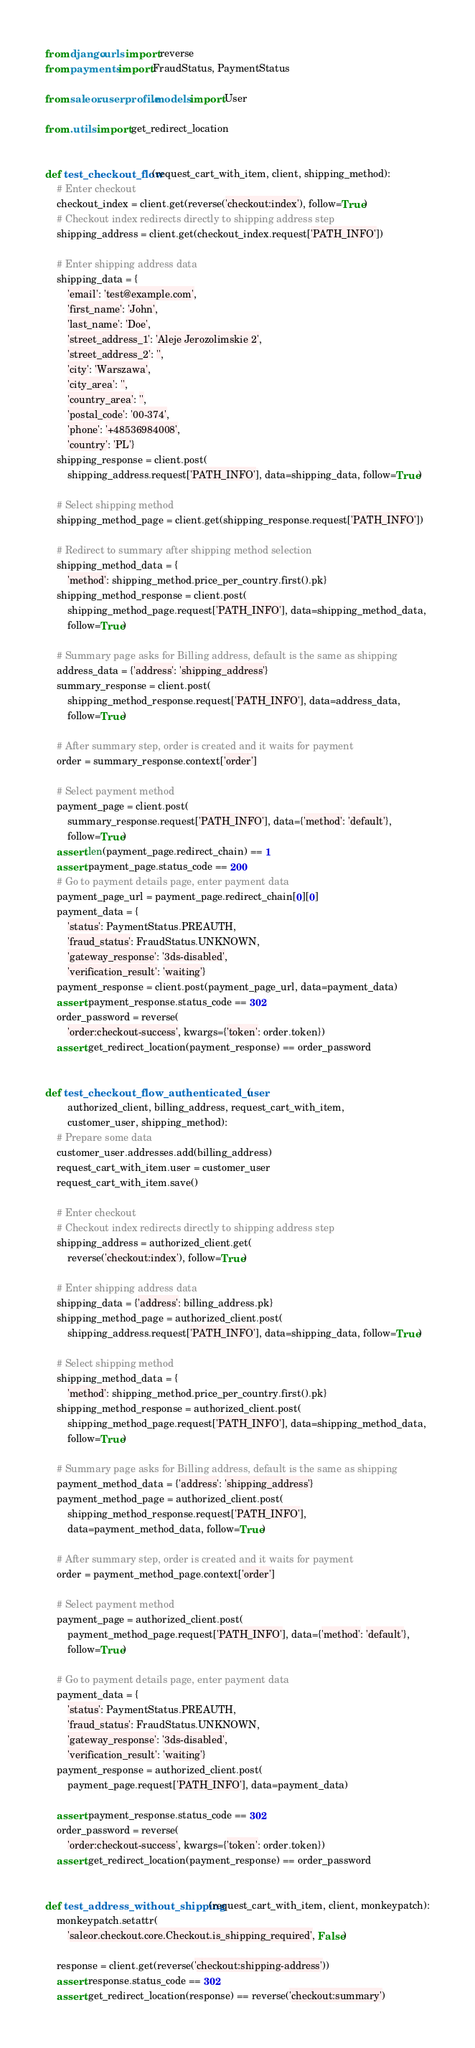Convert code to text. <code><loc_0><loc_0><loc_500><loc_500><_Python_>from django.urls import reverse
from payments import FraudStatus, PaymentStatus

from saleor.userprofile.models import User

from .utils import get_redirect_location


def test_checkout_flow(request_cart_with_item, client, shipping_method):
    # Enter checkout
    checkout_index = client.get(reverse('checkout:index'), follow=True)
    # Checkout index redirects directly to shipping address step
    shipping_address = client.get(checkout_index.request['PATH_INFO'])

    # Enter shipping address data
    shipping_data = {
        'email': 'test@example.com',
        'first_name': 'John',
        'last_name': 'Doe',
        'street_address_1': 'Aleje Jerozolimskie 2',
        'street_address_2': '',
        'city': 'Warszawa',
        'city_area': '',
        'country_area': '',
        'postal_code': '00-374',
        'phone': '+48536984008',
        'country': 'PL'}
    shipping_response = client.post(
        shipping_address.request['PATH_INFO'], data=shipping_data, follow=True)

    # Select shipping method
    shipping_method_page = client.get(shipping_response.request['PATH_INFO'])

    # Redirect to summary after shipping method selection
    shipping_method_data = {
        'method': shipping_method.price_per_country.first().pk}
    shipping_method_response = client.post(
        shipping_method_page.request['PATH_INFO'], data=shipping_method_data,
        follow=True)

    # Summary page asks for Billing address, default is the same as shipping
    address_data = {'address': 'shipping_address'}
    summary_response = client.post(
        shipping_method_response.request['PATH_INFO'], data=address_data,
        follow=True)

    # After summary step, order is created and it waits for payment
    order = summary_response.context['order']

    # Select payment method
    payment_page = client.post(
        summary_response.request['PATH_INFO'], data={'method': 'default'},
        follow=True)
    assert len(payment_page.redirect_chain) == 1
    assert payment_page.status_code == 200
    # Go to payment details page, enter payment data
    payment_page_url = payment_page.redirect_chain[0][0]
    payment_data = {
        'status': PaymentStatus.PREAUTH,
        'fraud_status': FraudStatus.UNKNOWN,
        'gateway_response': '3ds-disabled',
        'verification_result': 'waiting'}
    payment_response = client.post(payment_page_url, data=payment_data)
    assert payment_response.status_code == 302
    order_password = reverse(
        'order:checkout-success', kwargs={'token': order.token})
    assert get_redirect_location(payment_response) == order_password


def test_checkout_flow_authenticated_user(
        authorized_client, billing_address, request_cart_with_item,
        customer_user, shipping_method):
    # Prepare some data
    customer_user.addresses.add(billing_address)
    request_cart_with_item.user = customer_user
    request_cart_with_item.save()

    # Enter checkout
    # Checkout index redirects directly to shipping address step
    shipping_address = authorized_client.get(
        reverse('checkout:index'), follow=True)

    # Enter shipping address data
    shipping_data = {'address': billing_address.pk}
    shipping_method_page = authorized_client.post(
        shipping_address.request['PATH_INFO'], data=shipping_data, follow=True)

    # Select shipping method
    shipping_method_data = {
        'method': shipping_method.price_per_country.first().pk}
    shipping_method_response = authorized_client.post(
        shipping_method_page.request['PATH_INFO'], data=shipping_method_data,
        follow=True)

    # Summary page asks for Billing address, default is the same as shipping
    payment_method_data = {'address': 'shipping_address'}
    payment_method_page = authorized_client.post(
        shipping_method_response.request['PATH_INFO'],
        data=payment_method_data, follow=True)

    # After summary step, order is created and it waits for payment
    order = payment_method_page.context['order']

    # Select payment method
    payment_page = authorized_client.post(
        payment_method_page.request['PATH_INFO'], data={'method': 'default'},
        follow=True)

    # Go to payment details page, enter payment data
    payment_data = {
        'status': PaymentStatus.PREAUTH,
        'fraud_status': FraudStatus.UNKNOWN,
        'gateway_response': '3ds-disabled',
        'verification_result': 'waiting'}
    payment_response = authorized_client.post(
        payment_page.request['PATH_INFO'], data=payment_data)

    assert payment_response.status_code == 302
    order_password = reverse(
        'order:checkout-success', kwargs={'token': order.token})
    assert get_redirect_location(payment_response) == order_password


def test_address_without_shipping(request_cart_with_item, client, monkeypatch):
    monkeypatch.setattr(
        'saleor.checkout.core.Checkout.is_shipping_required', False)

    response = client.get(reverse('checkout:shipping-address'))
    assert response.status_code == 302
    assert get_redirect_location(response) == reverse('checkout:summary')

</code> 